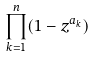Convert formula to latex. <formula><loc_0><loc_0><loc_500><loc_500>\prod _ { k = 1 } ^ { n } ( 1 - z ^ { a _ { k } } )</formula> 